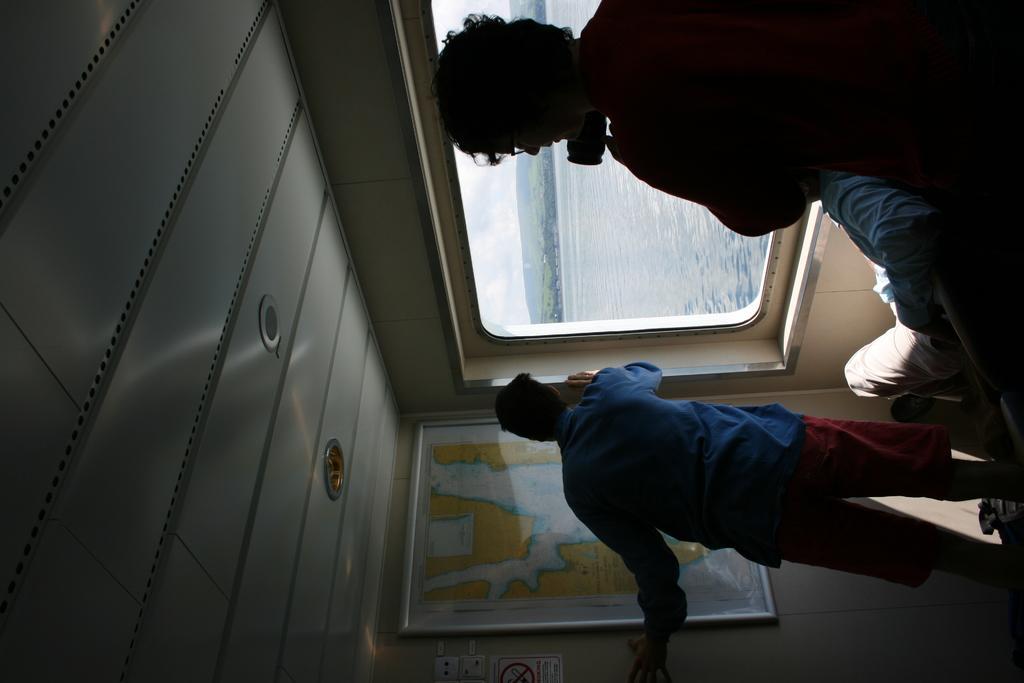How would you summarize this image in a sentence or two? On the right side there is a person holding a camera and wearing specs. Another person is siting. Also there is a person standing. And there is a window and a wall. On the wall there is a map and a sign board. Through the window we can see water and sky. 